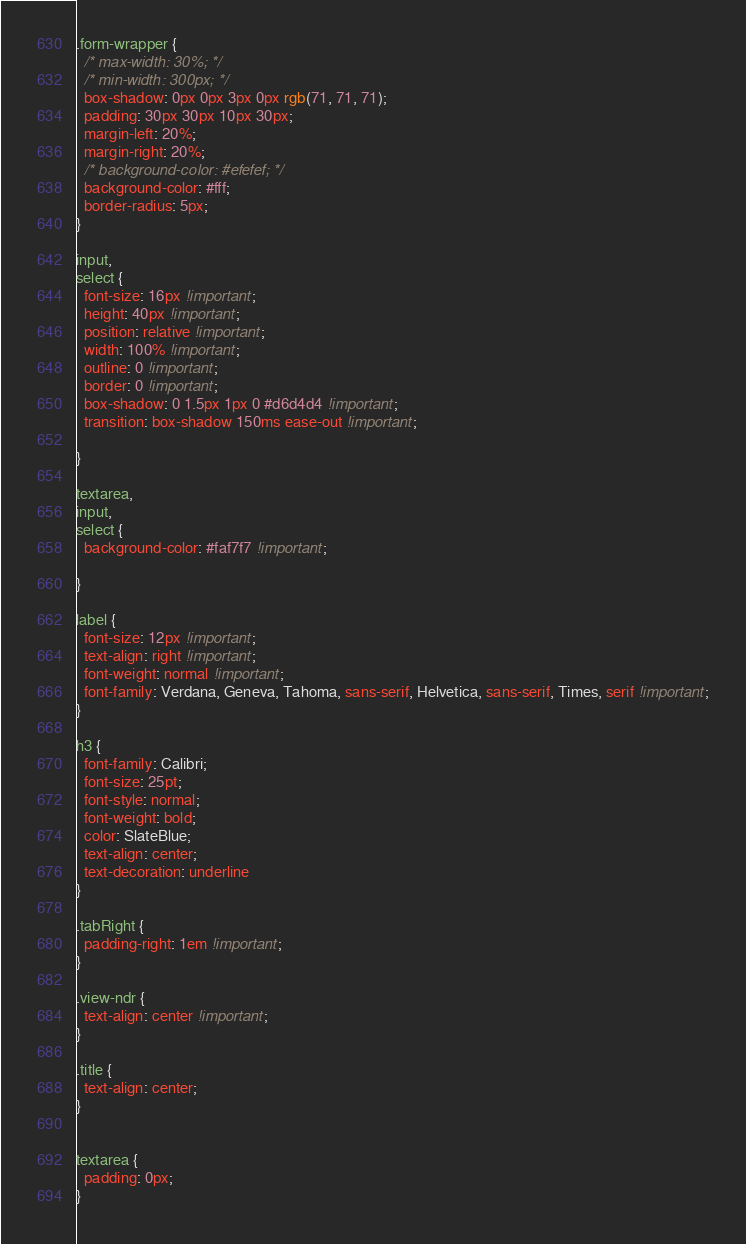Convert code to text. <code><loc_0><loc_0><loc_500><loc_500><_CSS_>.form-wrapper {
  /* max-width: 30%; */
  /* min-width: 300px; */
  box-shadow: 0px 0px 3px 0px rgb(71, 71, 71);
  padding: 30px 30px 10px 30px;
  margin-left: 20%;
  margin-right: 20%;
  /* background-color: #efefef; */
  background-color: #fff;
  border-radius: 5px;
}

input,
select {
  font-size: 16px !important;
  height: 40px !important;
  position: relative !important;
  width: 100% !important;
  outline: 0 !important;
  border: 0 !important;
  box-shadow: 0 1.5px 1px 0 #d6d4d4 !important;
  transition: box-shadow 150ms ease-out !important;

}

textarea,
input,
select {
  background-color: #faf7f7 !important;

}

label {
  font-size: 12px !important;
  text-align: right !important;
  font-weight: normal !important;
  font-family: Verdana, Geneva, Tahoma, sans-serif, Helvetica, sans-serif, Times, serif !important;
}

h3 {
  font-family: Calibri;
  font-size: 25pt;
  font-style: normal;
  font-weight: bold;
  color: SlateBlue;
  text-align: center;
  text-decoration: underline
}

.tabRight {
  padding-right: 1em !important;
}

.view-ndr {
  text-align: center !important;
}

.title {
  text-align: center;
}


textarea {
  padding: 0px;
}</code> 